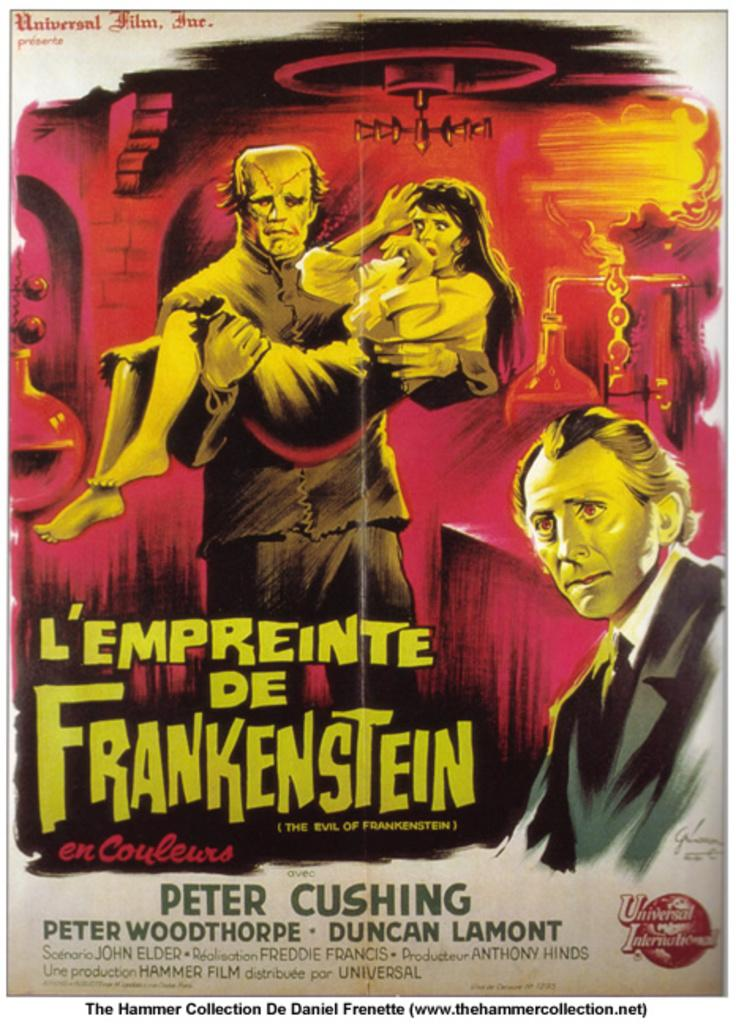<image>
Relay a brief, clear account of the picture shown. Cover for L'Empreinte De Frankenstein showing a monster carrying a woman. 